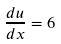Convert formula to latex. <formula><loc_0><loc_0><loc_500><loc_500>\frac { d u } { d x } = 6</formula> 